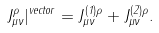<formula> <loc_0><loc_0><loc_500><loc_500>J ^ { \rho } _ { \mu \nu } | ^ { v e c t o r } = J ^ { ( 1 ) \rho } _ { \mu \nu } + J ^ { ( 2 ) \rho } _ { \mu \nu } .</formula> 